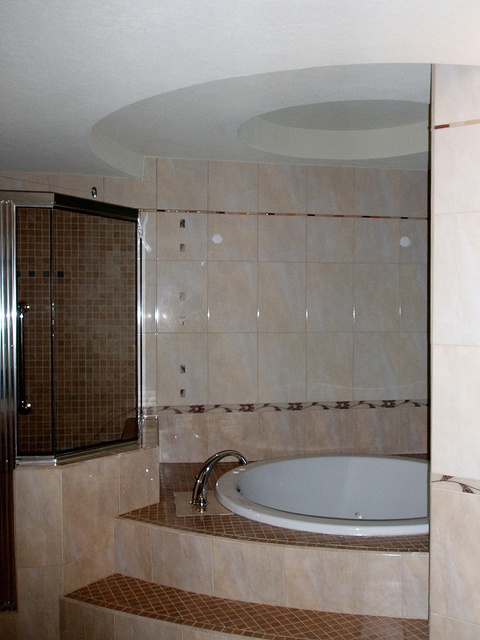Describe the objects in this image and their specific colors. I can see various objects in this image with different colors. 